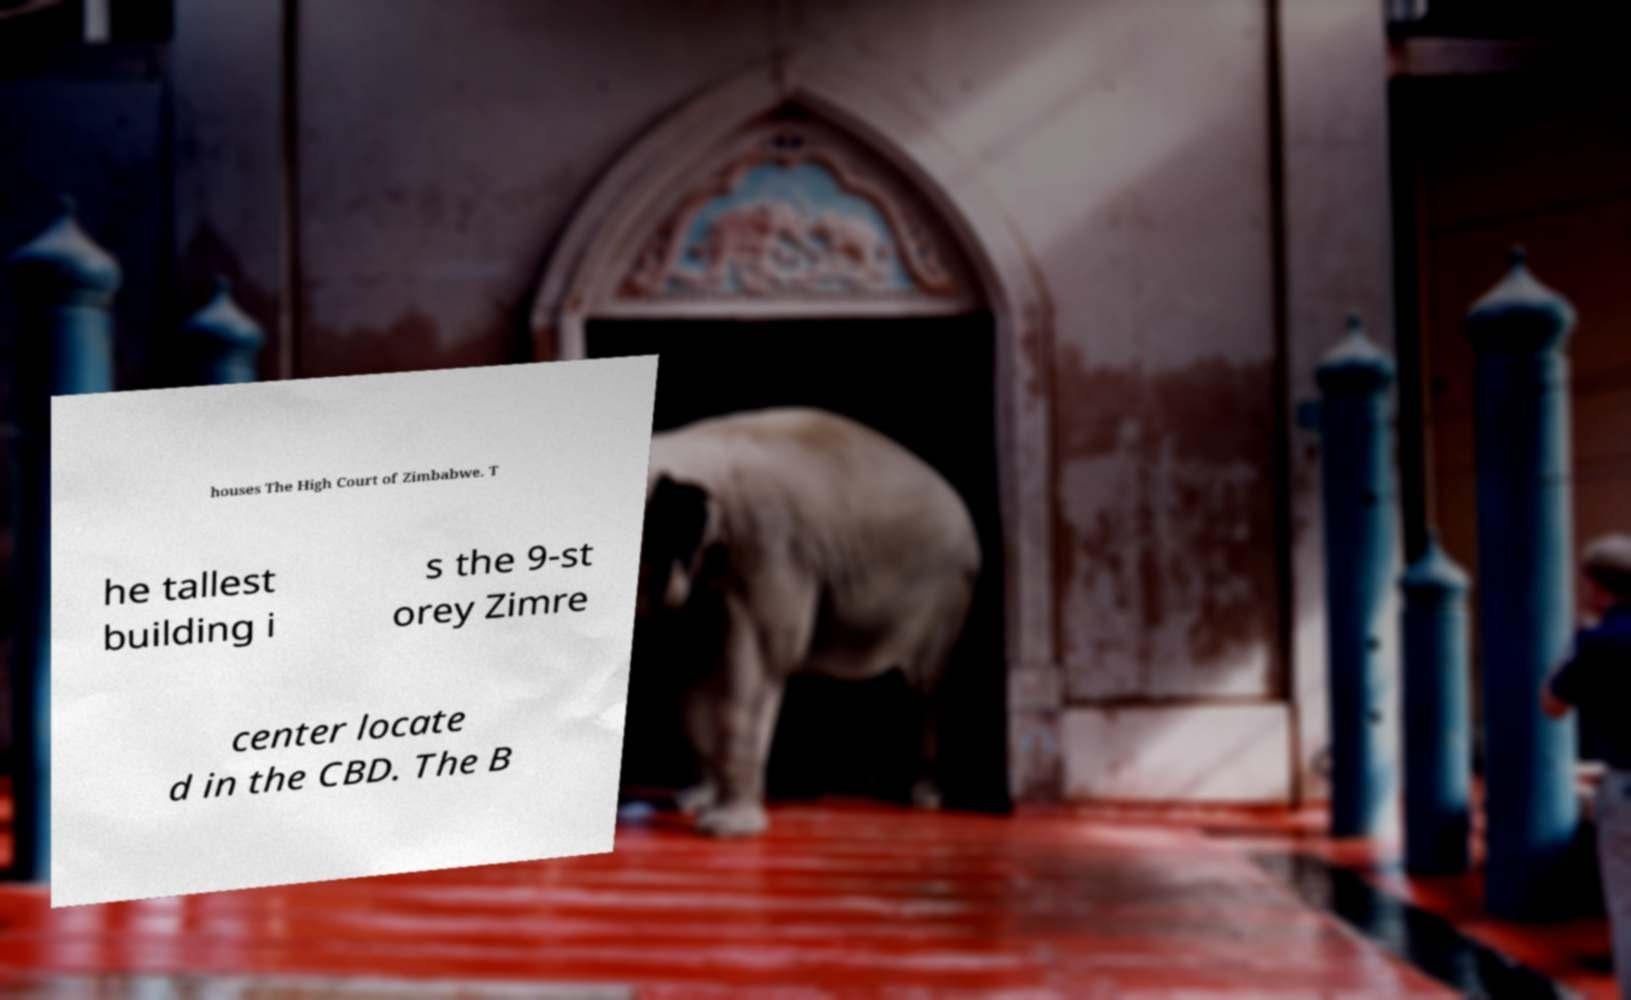Could you extract and type out the text from this image? houses The High Court of Zimbabwe. T he tallest building i s the 9-st orey Zimre center locate d in the CBD. The B 